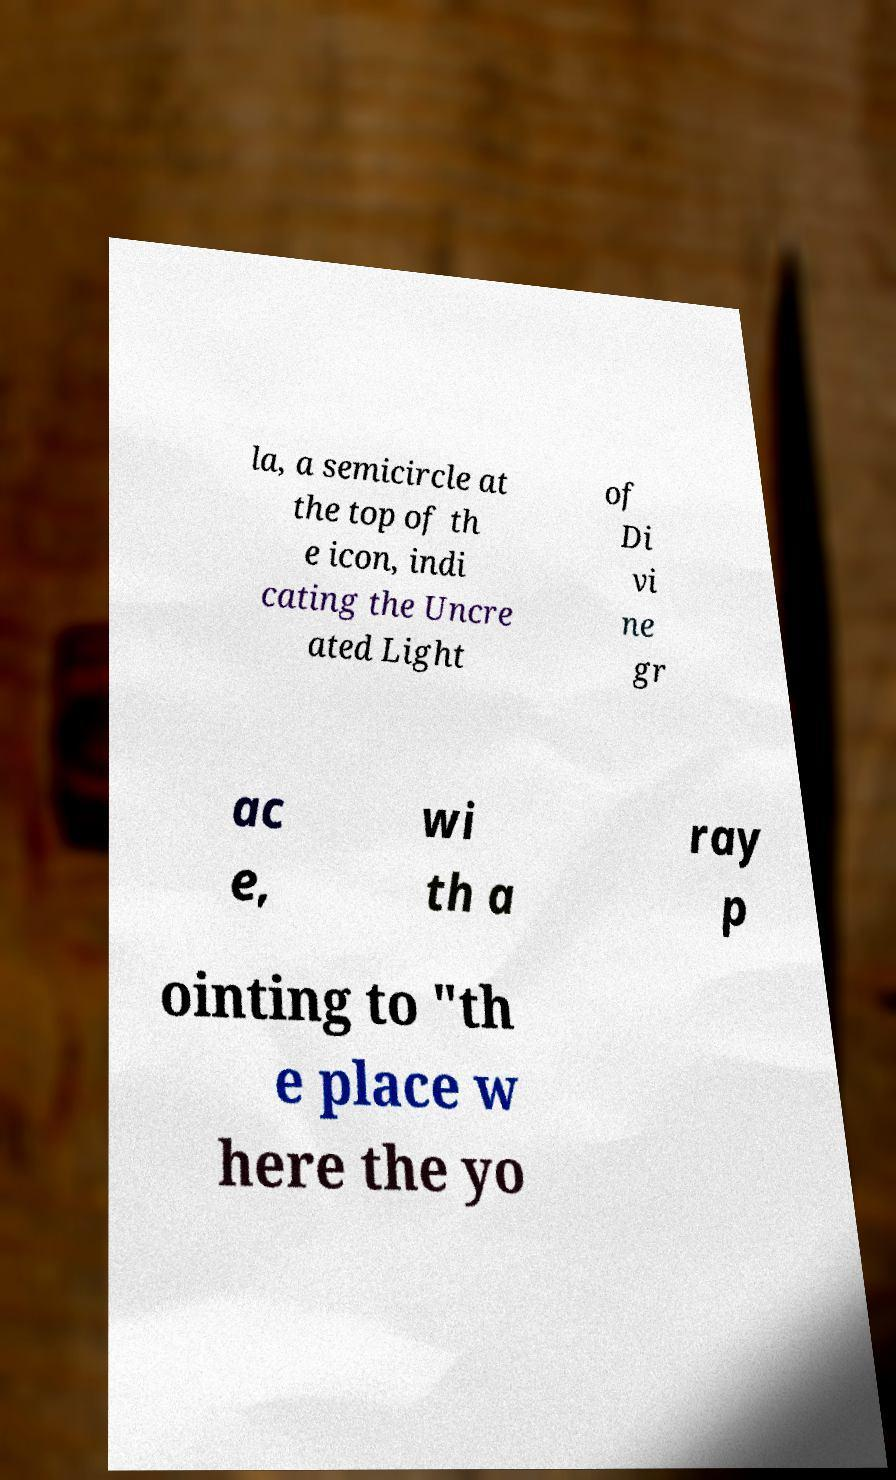I need the written content from this picture converted into text. Can you do that? la, a semicircle at the top of th e icon, indi cating the Uncre ated Light of Di vi ne gr ac e, wi th a ray p ointing to "th e place w here the yo 